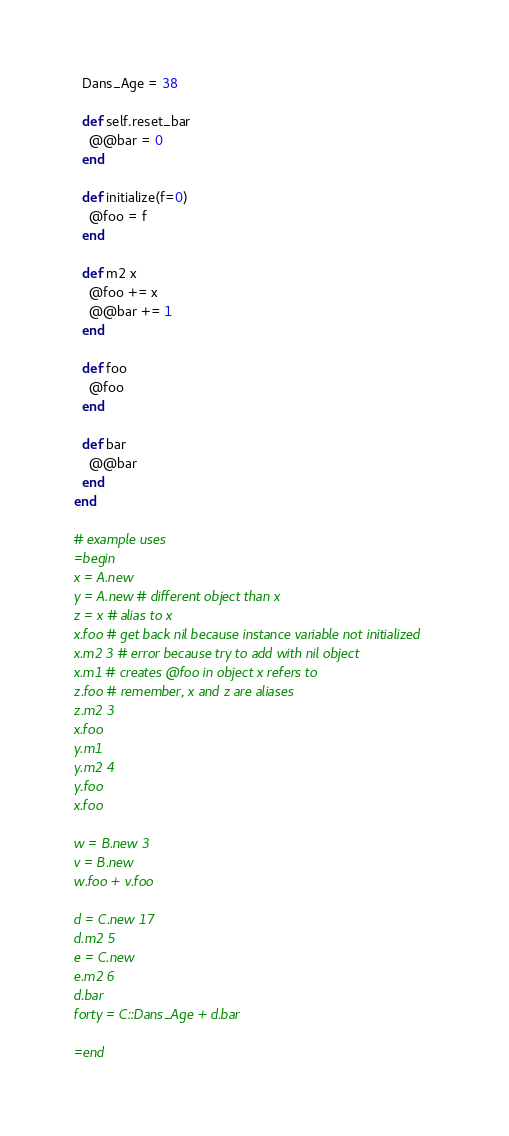Convert code to text. <code><loc_0><loc_0><loc_500><loc_500><_Ruby_>  Dans_Age = 38

  def self.reset_bar
    @@bar = 0
  end

  def initialize(f=0)
    @foo = f
  end

  def m2 x
    @foo += x
    @@bar += 1
  end

  def foo
    @foo
  end
  
  def bar
    @@bar
  end
end

# example uses 
=begin
x = A.new
y = A.new # different object than x
z = x # alias to x
x.foo # get back nil because instance variable not initialized
x.m2 3 # error because try to add with nil object
x.m1 # creates @foo in object x refers to
z.foo # remember, x and z are aliases
z.m2 3
x.foo
y.m1
y.m2 4
y.foo
x.foo

w = B.new 3
v = B.new
w.foo + v.foo

d = C.new 17
d.m2 5
e = C.new
e.m2 6
d.bar
forty = C::Dans_Age + d.bar

=end
</code> 